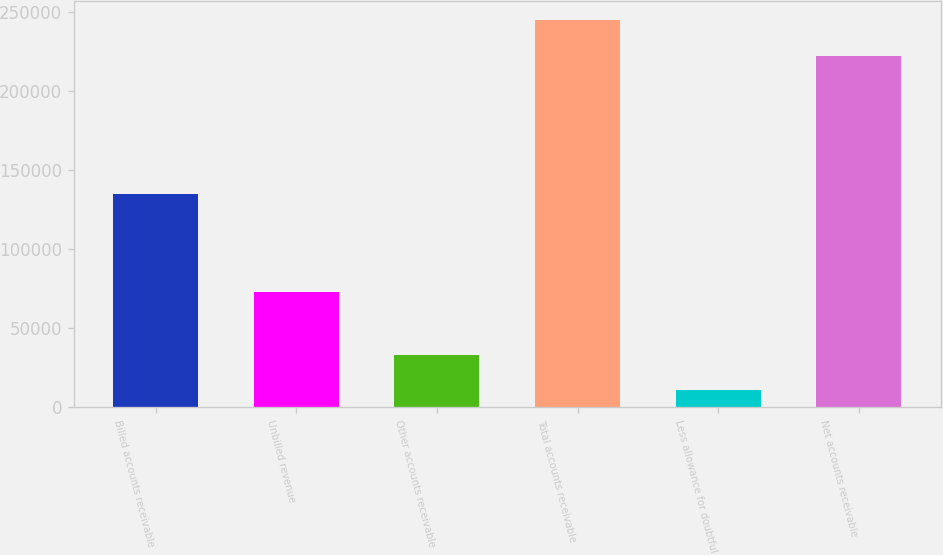<chart> <loc_0><loc_0><loc_500><loc_500><bar_chart><fcel>Billed accounts receivable<fcel>Unbilled revenue<fcel>Other accounts receivable<fcel>Total accounts receivable<fcel>Less allowance for doubtful<fcel>Net accounts receivable<nl><fcel>135091<fcel>73143<fcel>33091.3<fcel>244489<fcel>10865<fcel>222263<nl></chart> 